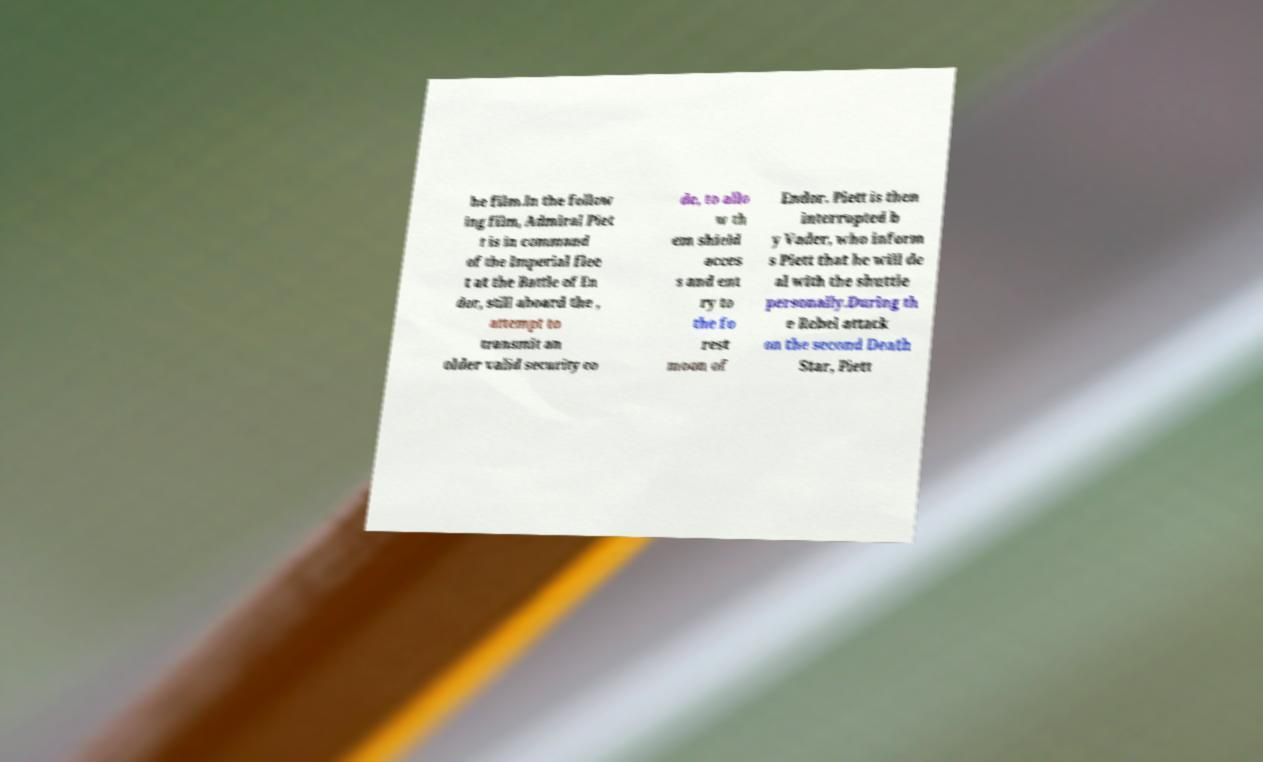There's text embedded in this image that I need extracted. Can you transcribe it verbatim? he film.In the follow ing film, Admiral Piet t is in command of the Imperial flee t at the Battle of En dor, still aboard the , attempt to transmit an older valid security co de, to allo w th em shield acces s and ent ry to the fo rest moon of Endor. Piett is then interrupted b y Vader, who inform s Piett that he will de al with the shuttle personally.During th e Rebel attack on the second Death Star, Piett 